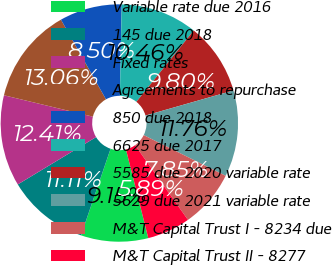Convert chart to OTSL. <chart><loc_0><loc_0><loc_500><loc_500><pie_chart><fcel>Variable rate due 2016<fcel>145 due 2018<fcel>Fixed rates<fcel>Agreements to repurchase<fcel>850 due 2018<fcel>6625 due 2017<fcel>5585 due 2020 variable rate<fcel>5629 due 2021 variable rate<fcel>M&T Capital Trust I - 8234 due<fcel>M&T Capital Trust II - 8277<nl><fcel>9.15%<fcel>11.11%<fcel>12.41%<fcel>13.06%<fcel>8.5%<fcel>10.46%<fcel>9.8%<fcel>11.76%<fcel>7.85%<fcel>5.89%<nl></chart> 